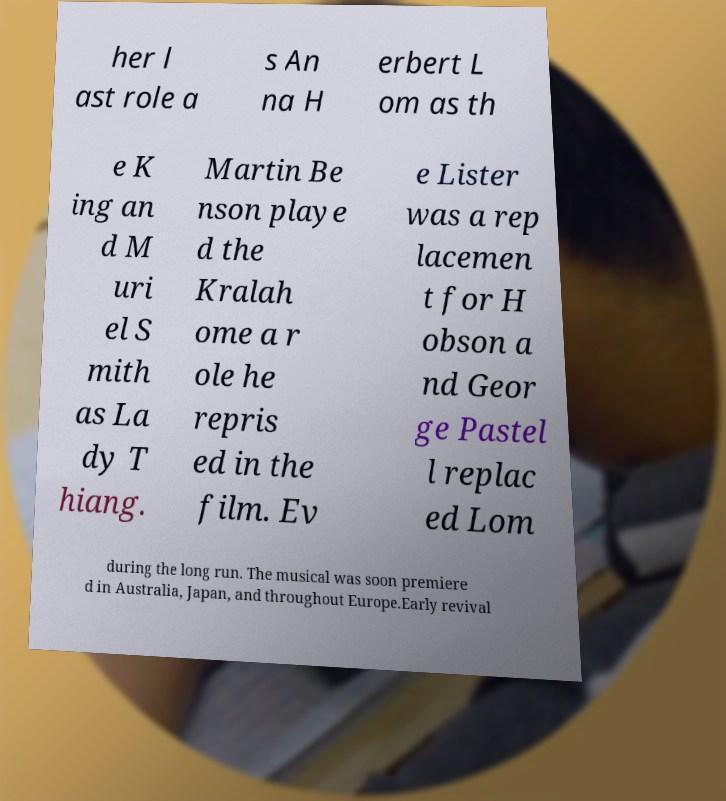Can you read and provide the text displayed in the image?This photo seems to have some interesting text. Can you extract and type it out for me? her l ast role a s An na H erbert L om as th e K ing an d M uri el S mith as La dy T hiang. Martin Be nson playe d the Kralah ome a r ole he repris ed in the film. Ev e Lister was a rep lacemen t for H obson a nd Geor ge Pastel l replac ed Lom during the long run. The musical was soon premiere d in Australia, Japan, and throughout Europe.Early revival 